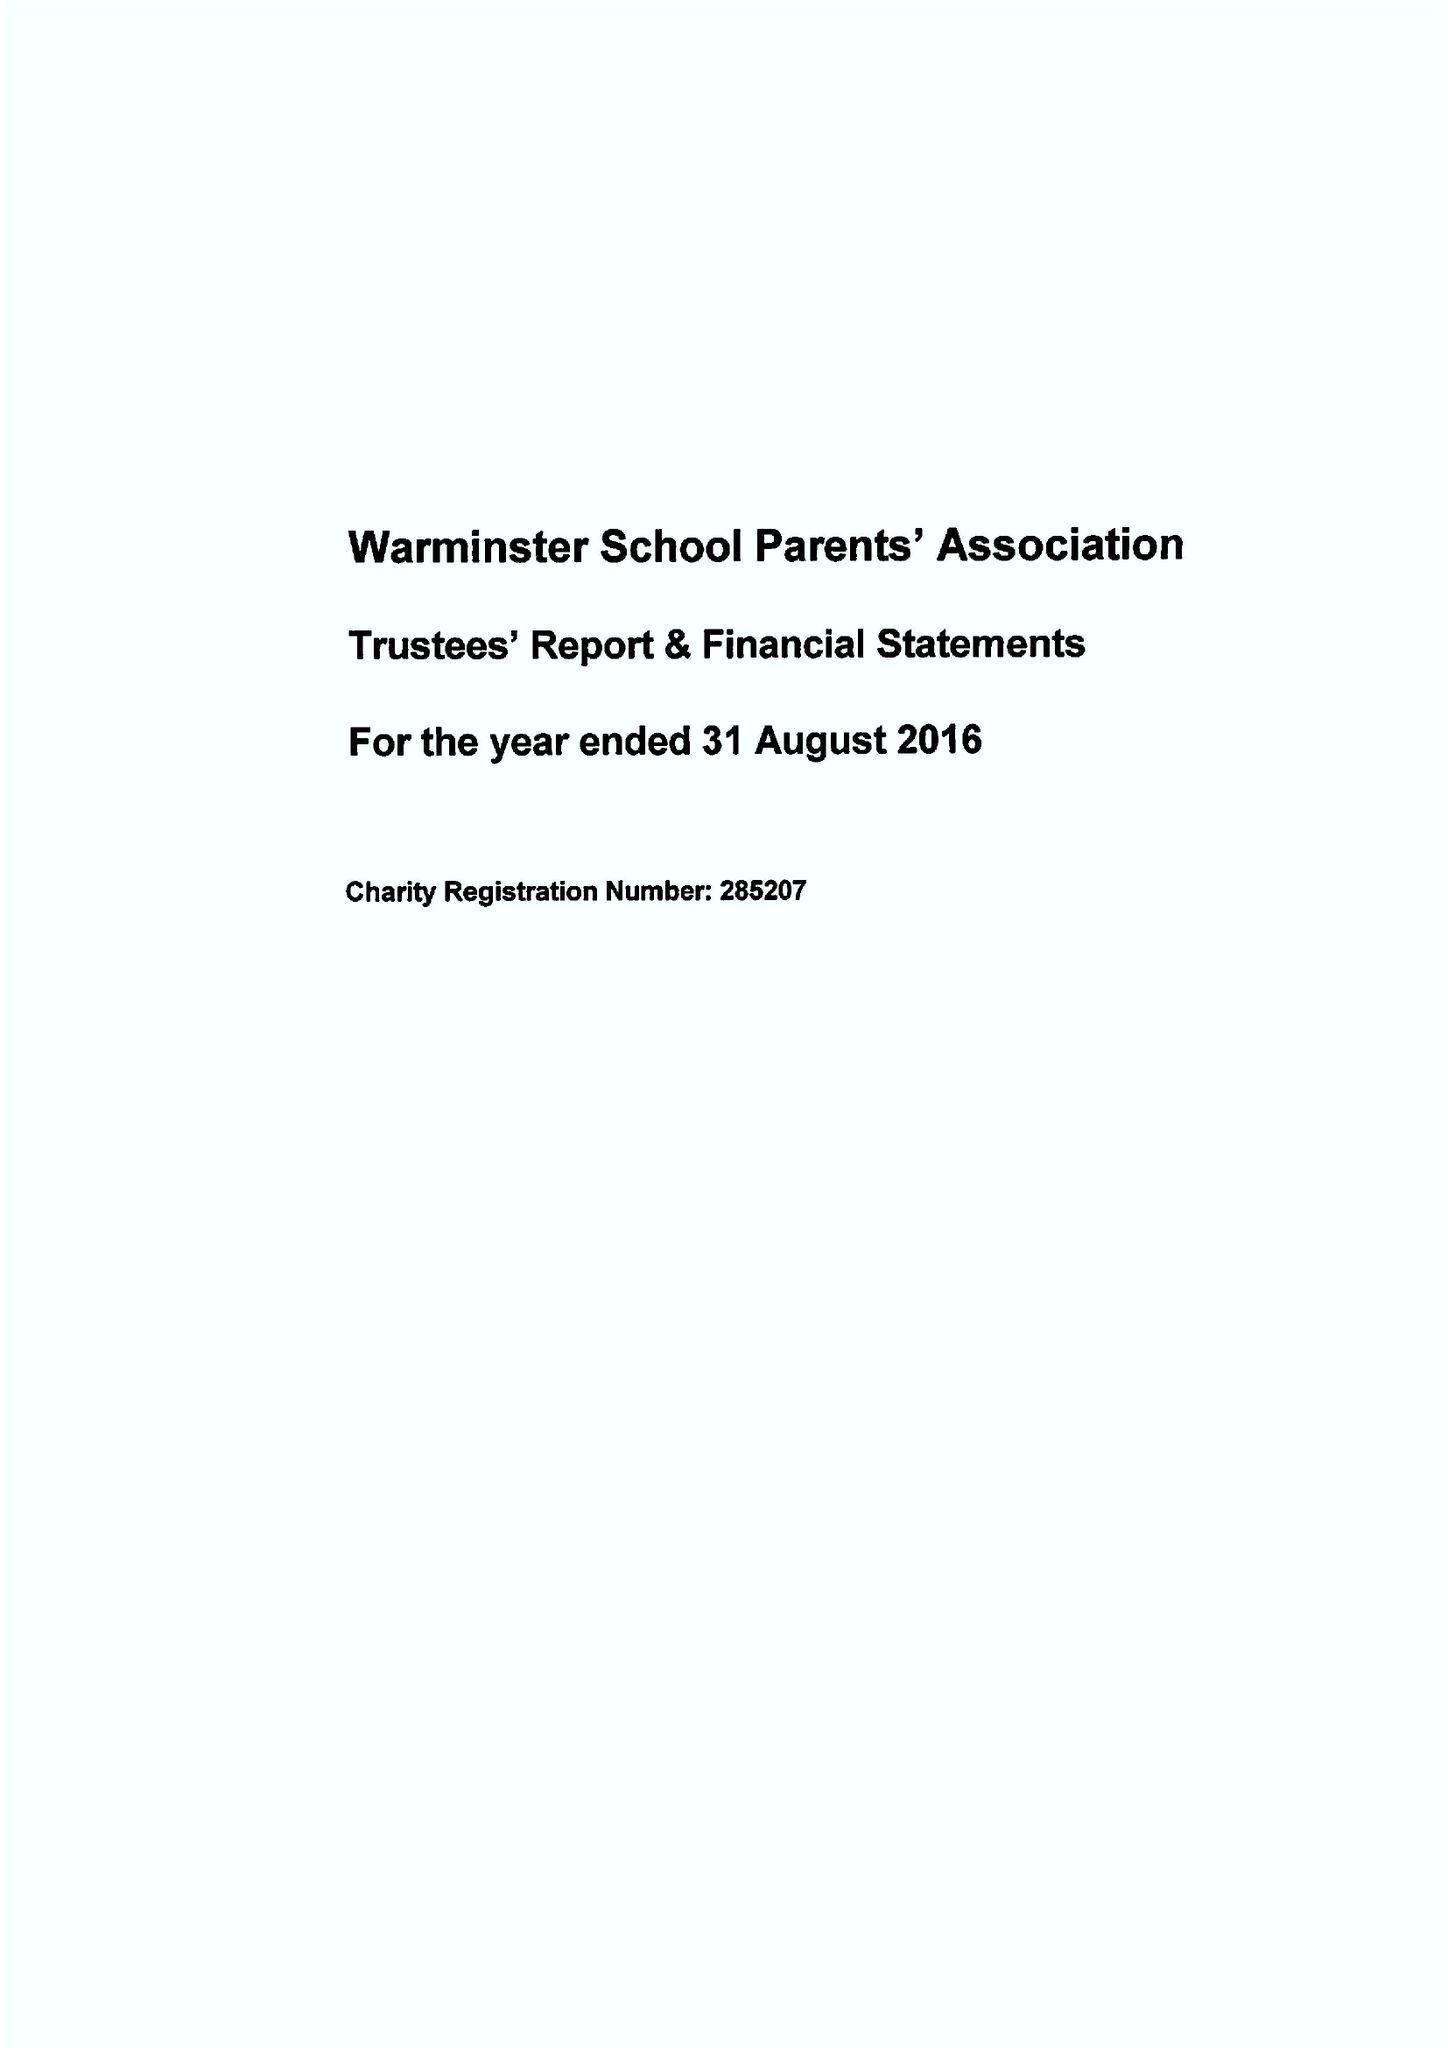What is the value for the address__post_town?
Answer the question using a single word or phrase. WARMINSTER 